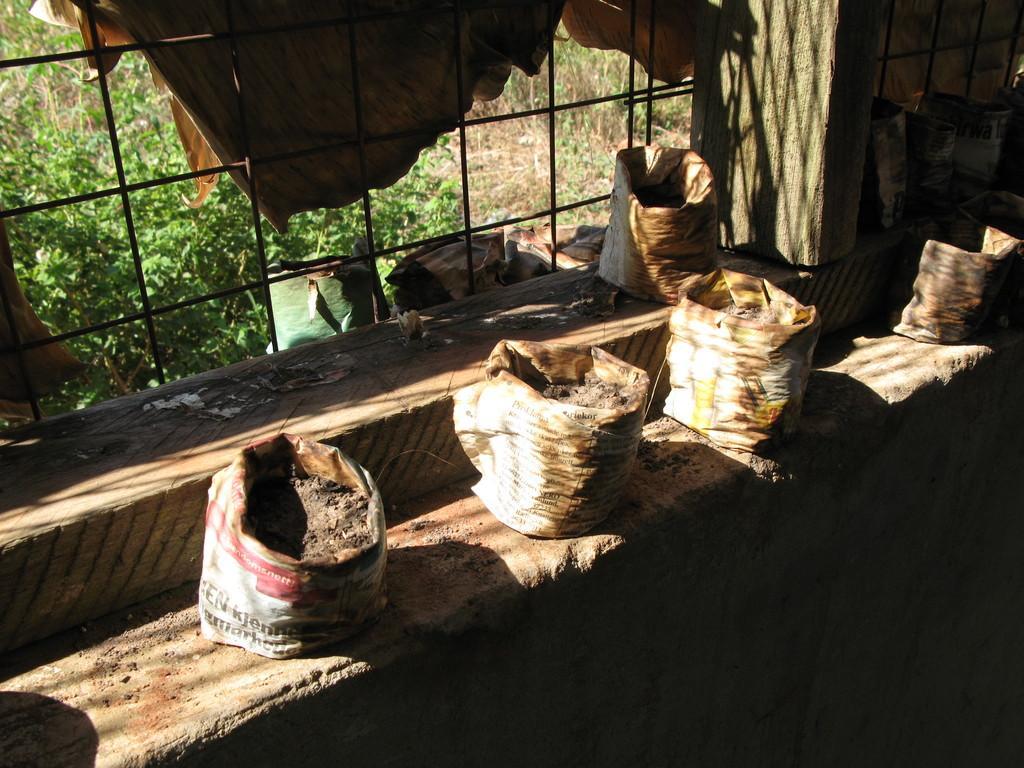In one or two sentences, can you explain what this image depicts? In this image we can see bags with soil on the platform. In the background of the image there is a window. There is a curtain. There are plants. 